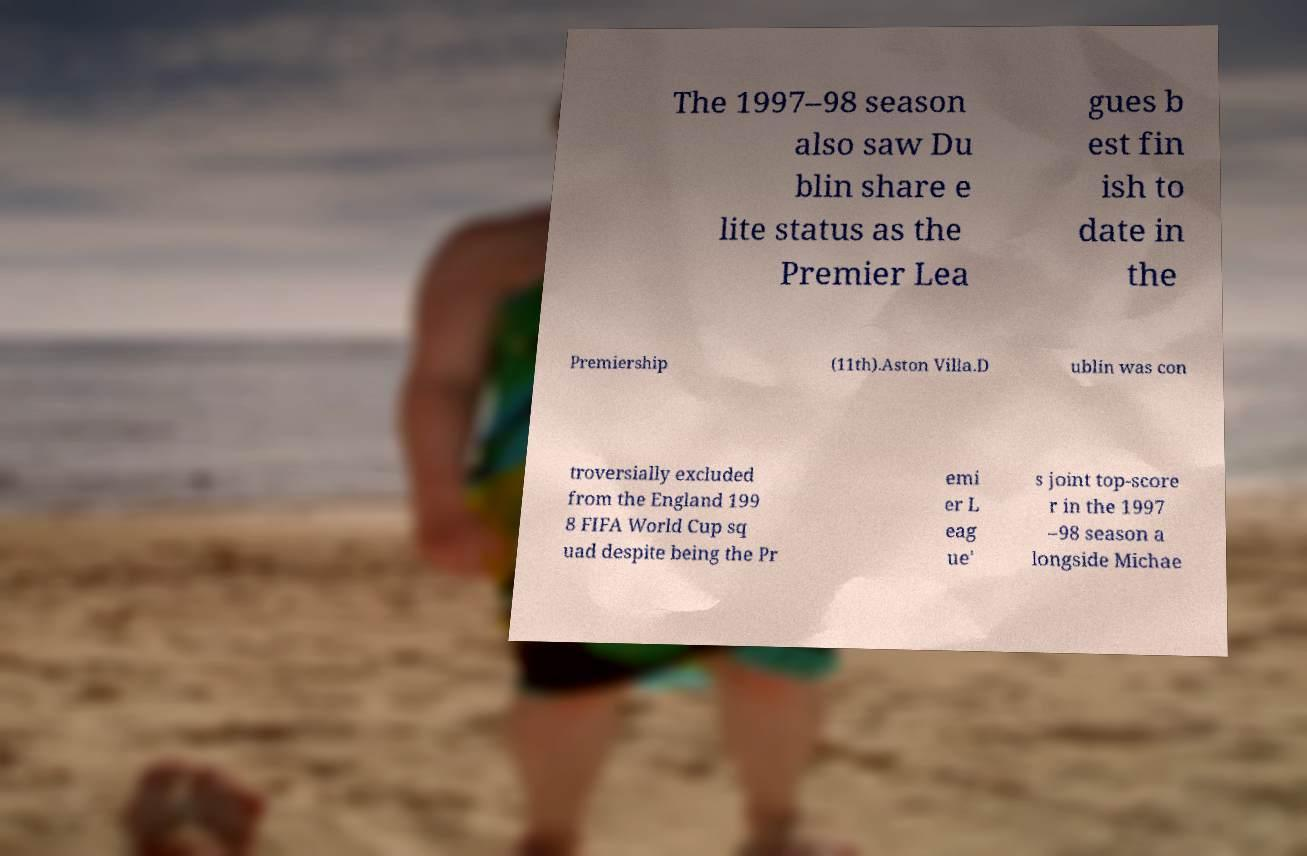What messages or text are displayed in this image? I need them in a readable, typed format. The 1997–98 season also saw Du blin share e lite status as the Premier Lea gues b est fin ish to date in the Premiership (11th).Aston Villa.D ublin was con troversially excluded from the England 199 8 FIFA World Cup sq uad despite being the Pr emi er L eag ue' s joint top-score r in the 1997 –98 season a longside Michae 